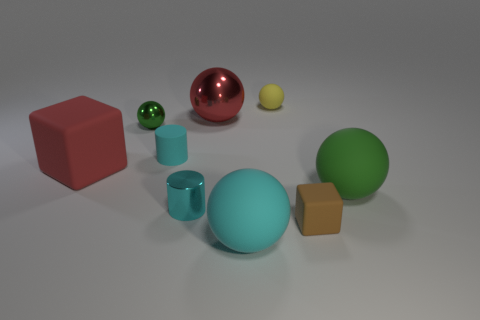Subtract all cyan matte balls. How many balls are left? 4 Subtract all cyan balls. How many balls are left? 4 Subtract 3 spheres. How many spheres are left? 2 Add 4 large red blocks. How many large red blocks exist? 5 Subtract 0 yellow cubes. How many objects are left? 9 Subtract all balls. How many objects are left? 4 Subtract all yellow cubes. Subtract all brown spheres. How many cubes are left? 2 Subtract all green cylinders. How many gray spheres are left? 0 Subtract all metallic objects. Subtract all small cyan things. How many objects are left? 4 Add 8 small shiny balls. How many small shiny balls are left? 9 